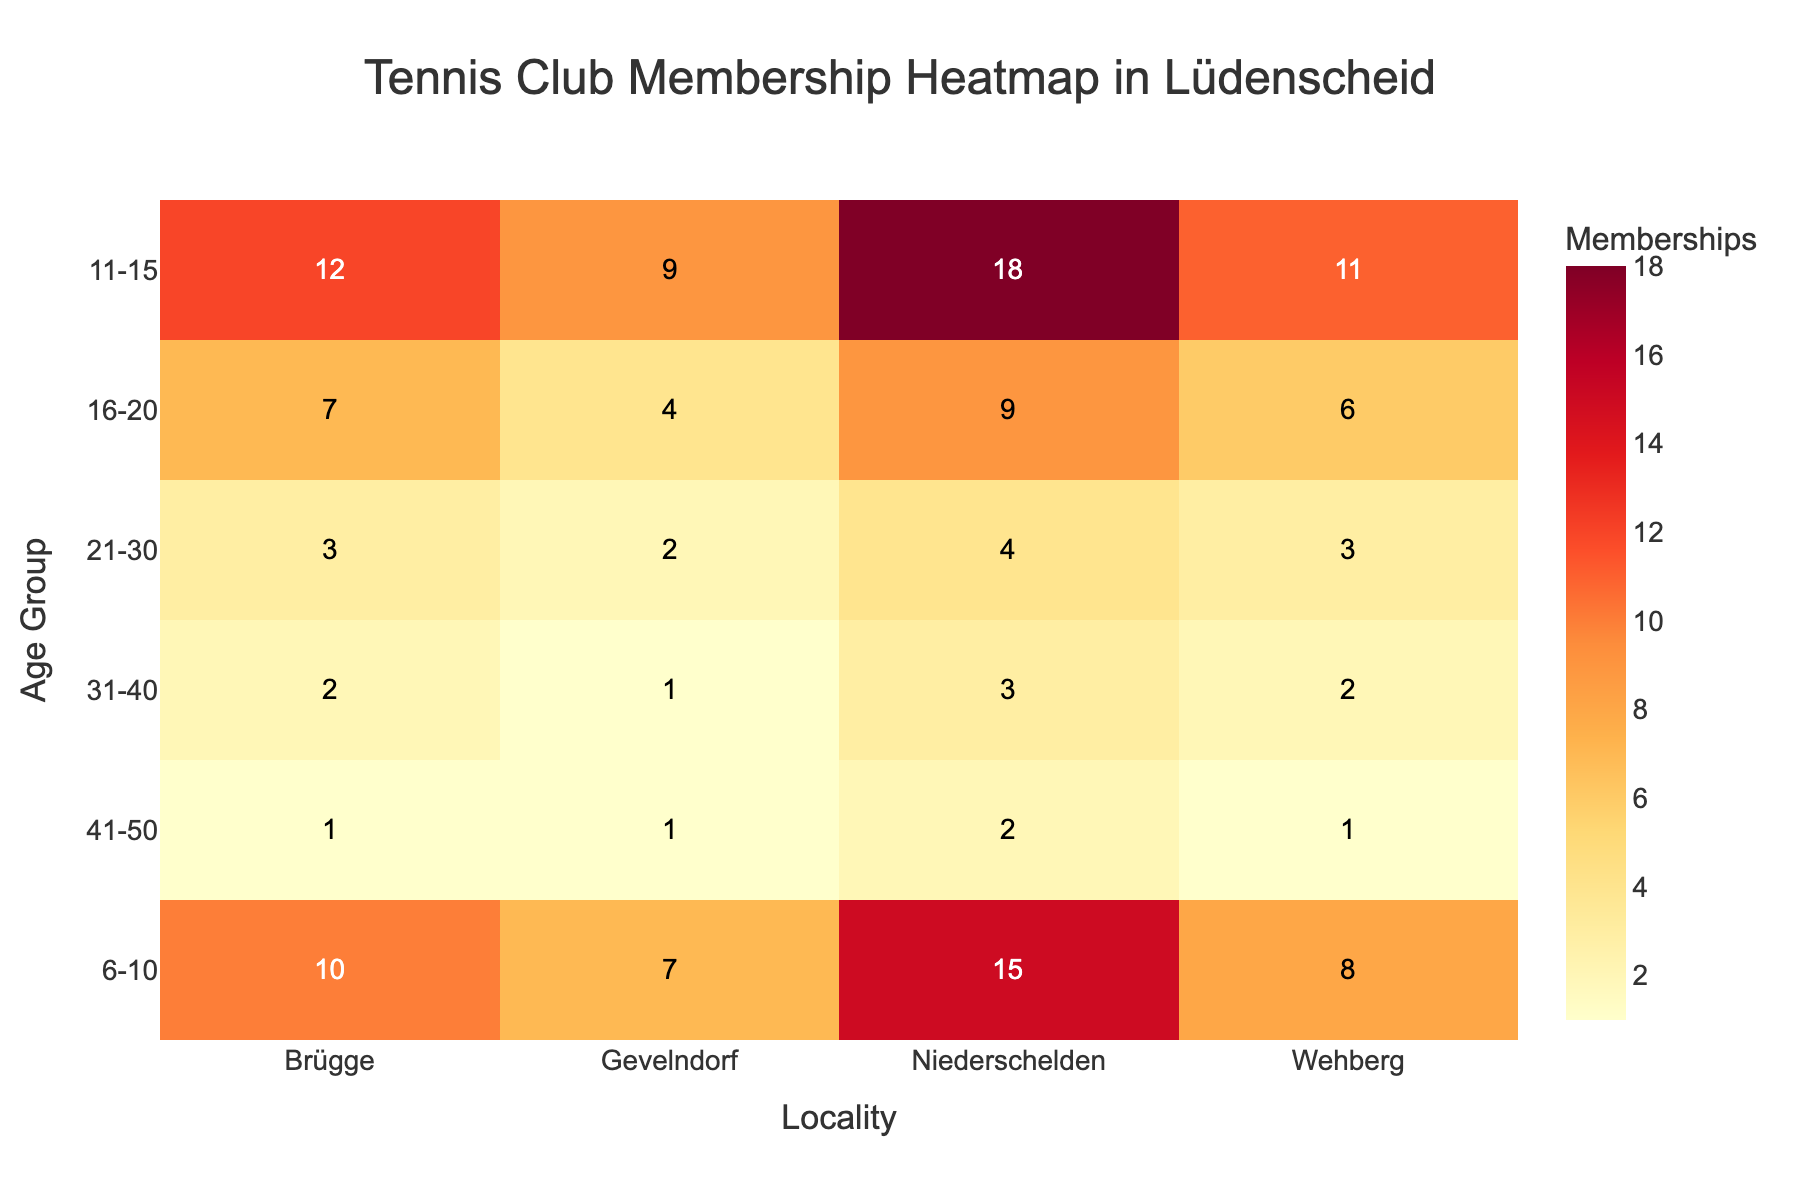What's the locality with the highest number of memberships for the age group 11-15? Look at the row corresponding to the age group 11-15 and identify the highest value. In this case, the highest number of memberships is 18 in Niederschelden.
Answer: Niederschelden Which age group has the least number of memberships in Brügge? Look at the column corresponding to Brügge and identify the lowest value. The least number of memberships is 1, found in the age group 41-50.
Answer: 41-50 How many age groups are represented in the heatmap? Count the number of unique age groups listed on the y-axis. There are 6 unique age groups.
Answer: 6 What is the total number of memberships in Wehberg across all age groups? Sum the membership values in the column for Wehberg. The total is 8 + 11 + 6 + 3 + 2 + 1 = 31.
Answer: 31 Which locality has the lowest overall membership for the age group 21-30? Look at the row for the age group 21-30 and identify the lowest value among the localities. Both Brügge and Wehberg have the lowest value of 3 memberships.
Answer: Brügge and Wehberg Is the memberships value for the age group 16-20 greater in Niederschelden or in Gevelndorf? Compare the values in the row for 16-20 for Niederschelden (9) and Gevelndorf (4). Niederschelden has a greater membership value.
Answer: Niederschelden What is the average number of memberships for the age group 6-10? Add up the memberships for age group 6-10 (10 + 7 + 15 + 8) and divide by the number of localities (4). The average is (10 + 7 + 15 + 8) / 4 = 10.
Answer: 10 Which age group has the highest cumulative memberships in Lüdenscheid? Calculate the sum of memberships for each age group across all localities, then identify the highest sum. Age group 11-15 has the highest sum: 12 + 9 + 18 + 11 = 50.
Answer: 11-15 